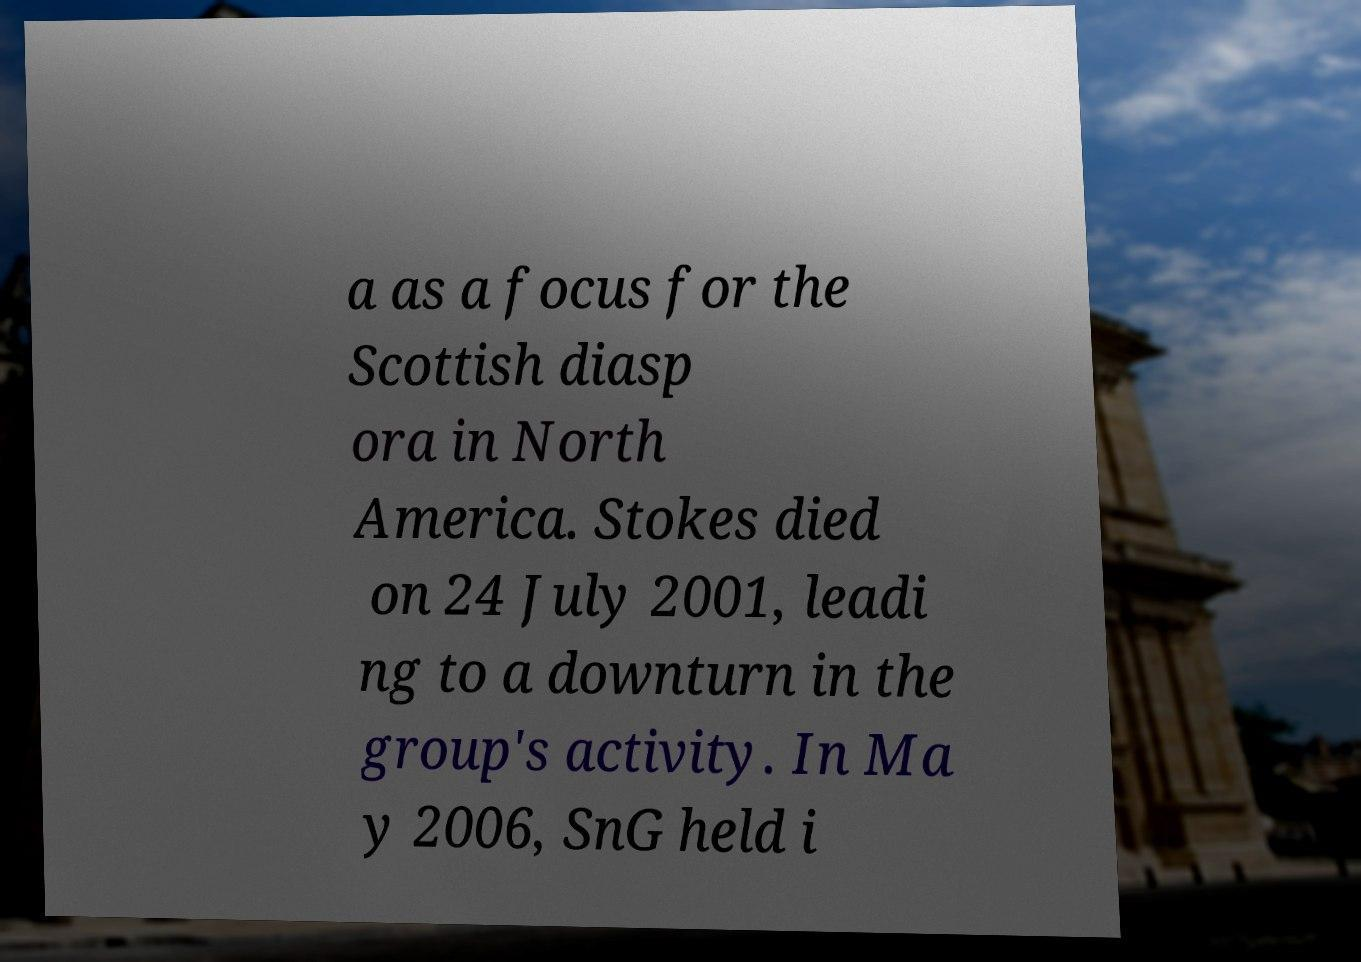Please read and relay the text visible in this image. What does it say? a as a focus for the Scottish diasp ora in North America. Stokes died on 24 July 2001, leadi ng to a downturn in the group's activity. In Ma y 2006, SnG held i 